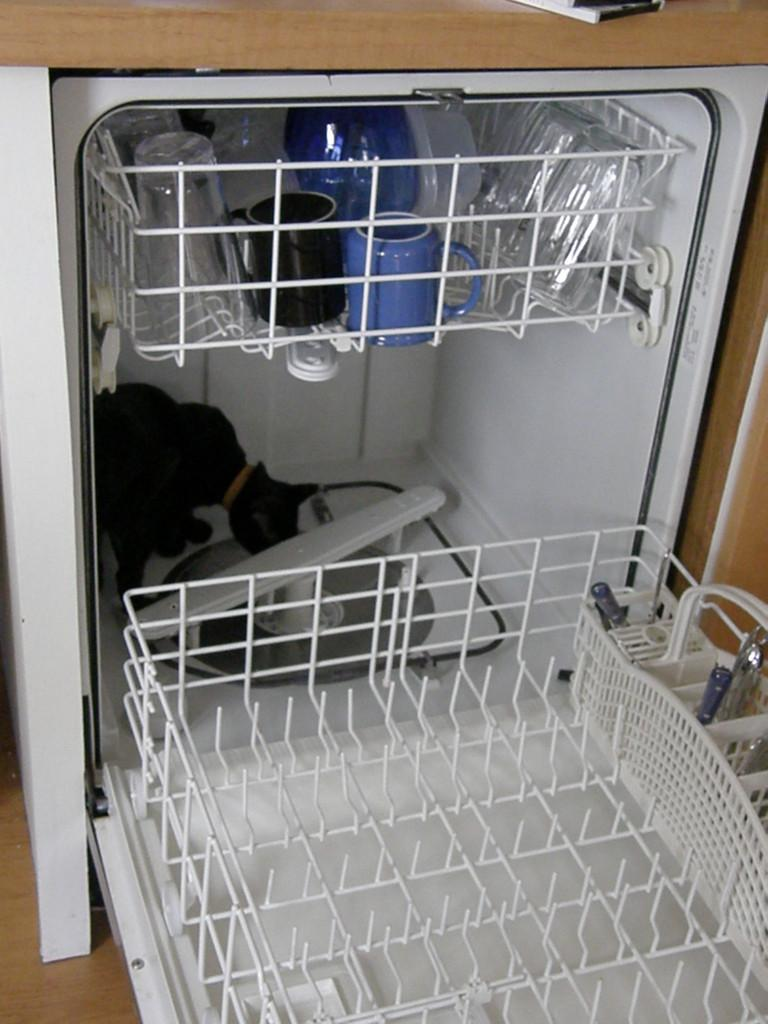What type of furniture is visible in the image? There is a cupboard with racks in the image. What can be found inside the cupboard? There are glasses, cups, and other items in the racks. Is there any living creature inside the cupboard? Yes, there is a cat inside the cupboard. What type of juice is being served by the cat in the image? There is no juice or cat serving juice in the image; the cat is simply inside the cupboard. 